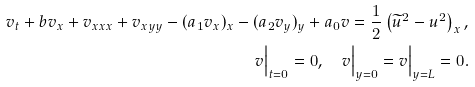<formula> <loc_0><loc_0><loc_500><loc_500>v _ { t } + b v _ { x } + v _ { x x x } + v _ { x y y } - ( a _ { 1 } v _ { x } ) _ { x } - ( a _ { 2 } v _ { y } ) _ { y } + a _ { 0 } v = \frac { 1 } { 2 } \left ( \widetilde { u } ^ { 2 } - u ^ { 2 } \right ) _ { x } , \\ v \Big | _ { t = 0 } = 0 , \quad v \Big | _ { y = 0 } = v \Big | _ { y = L } = 0 .</formula> 